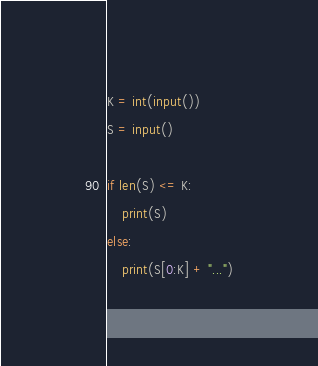<code> <loc_0><loc_0><loc_500><loc_500><_Python_>K = int(input())
S = input()

if len(S) <= K:
    print(S)
else:
    print(S[0:K] + "...")</code> 